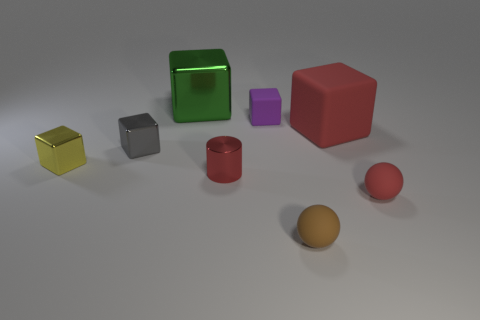Subtract all red matte blocks. How many blocks are left? 4 Subtract 3 cubes. How many cubes are left? 2 Add 1 tiny red cylinders. How many objects exist? 9 Subtract all gray blocks. How many blocks are left? 4 Subtract all yellow cubes. Subtract all red spheres. How many cubes are left? 4 Add 2 small blue cylinders. How many small blue cylinders exist? 2 Subtract 0 blue spheres. How many objects are left? 8 Subtract all cylinders. How many objects are left? 7 Subtract all tiny red metallic cylinders. Subtract all red things. How many objects are left? 4 Add 8 small metallic cylinders. How many small metallic cylinders are left? 9 